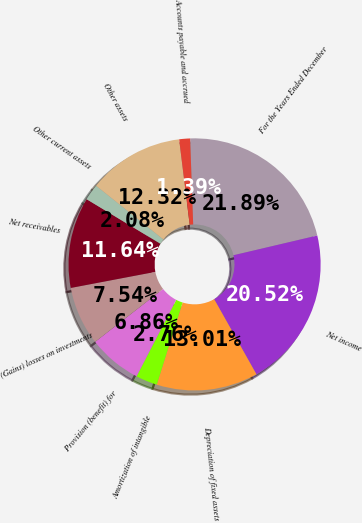Convert chart. <chart><loc_0><loc_0><loc_500><loc_500><pie_chart><fcel>For the Years Ended December<fcel>Net income<fcel>Depreciation of fixed assets<fcel>Amortization of intangible<fcel>Provision (benefit) for<fcel>(Gains) losses on investments<fcel>Net receivables<fcel>Other current assets<fcel>Other assets<fcel>Accounts payable and accrued<nl><fcel>21.89%<fcel>20.52%<fcel>13.01%<fcel>2.76%<fcel>6.86%<fcel>7.54%<fcel>11.64%<fcel>2.08%<fcel>12.32%<fcel>1.39%<nl></chart> 